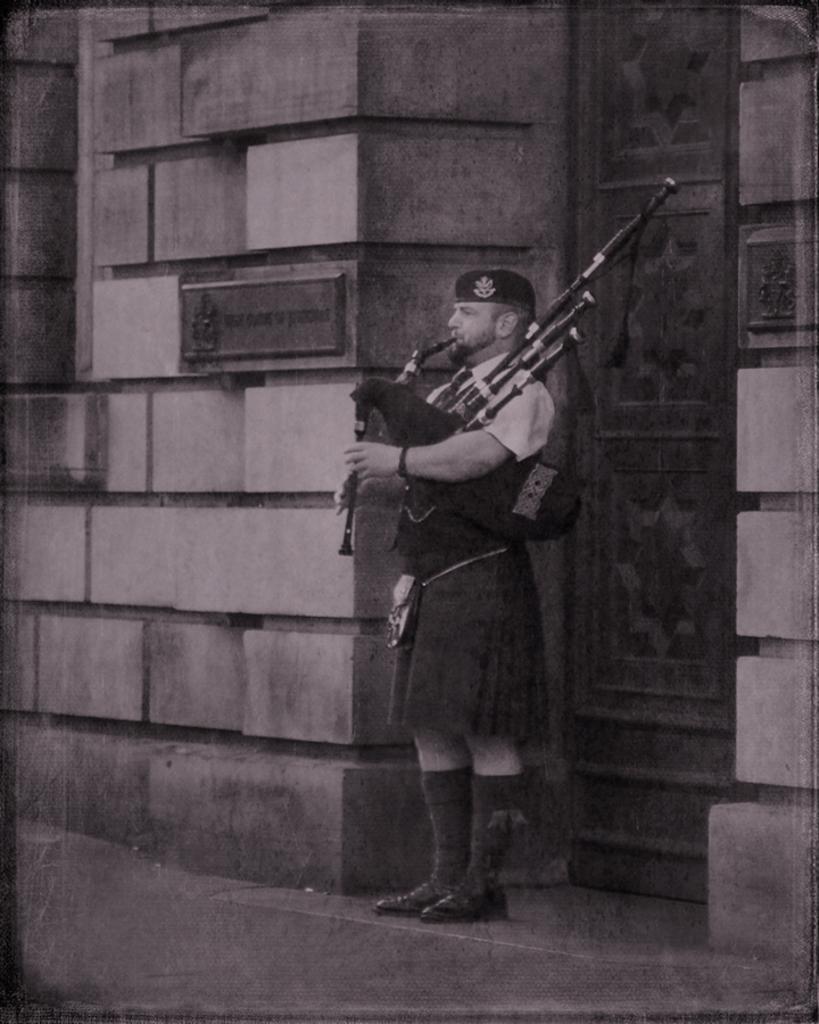Describe this image in one or two sentences. This is a black and white image. We can see a man is holding a musical instrument. Behind the man, there is a wall, door and a board. 